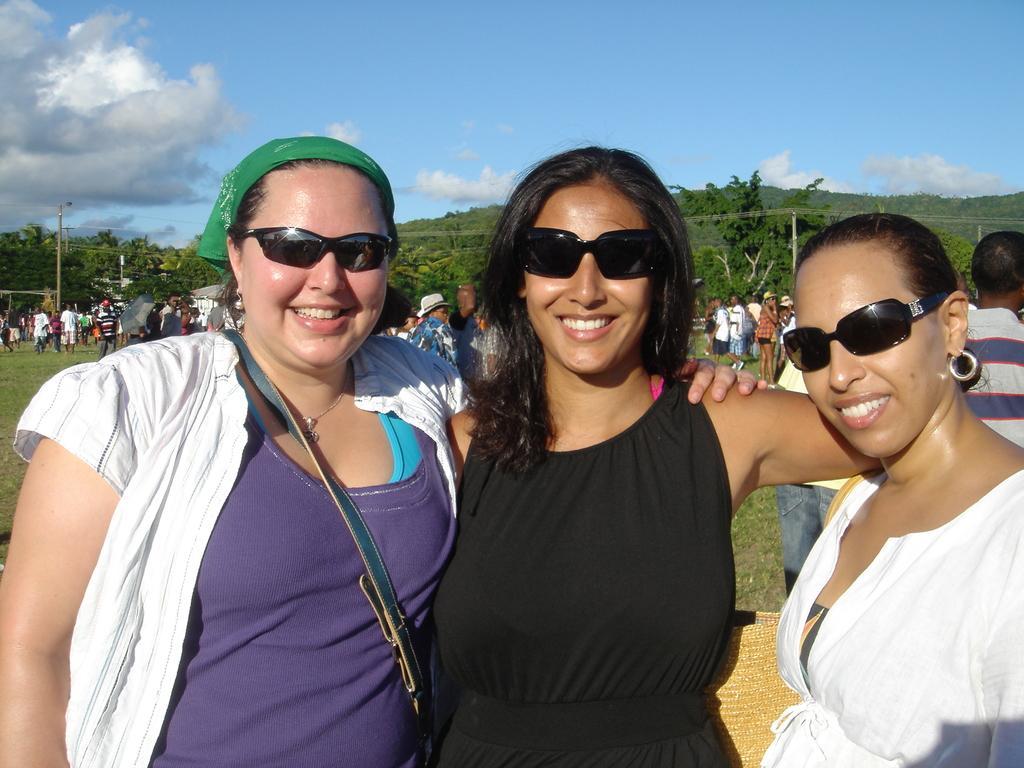In one or two sentences, can you explain what this image depicts? This picture shows few women standing. They wore sunglasses on their faces and we see a woman wore a cloth to her head and we see few people standing on the back and we see trees and a pole light and a blue cloudy sky. 